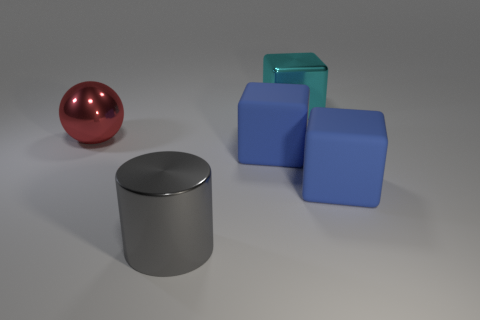There is a large metallic object that is in front of the red sphere; what is its color?
Offer a very short reply. Gray. Are there more shiny objects left of the gray cylinder than large yellow matte things?
Your answer should be very brief. Yes. The big sphere has what color?
Your answer should be compact. Red. There is a blue matte thing behind the large blue matte object that is on the right side of the thing that is behind the red ball; what shape is it?
Your answer should be very brief. Cube. What is the shape of the large metallic object behind the large metallic thing that is to the left of the large gray metal cylinder?
Your answer should be compact. Cube. There is a red metal sphere; is its size the same as the metal object right of the big gray metal cylinder?
Give a very brief answer. Yes. How many large things are blue rubber blocks or cylinders?
Your answer should be compact. 3. Is the number of large gray metallic cylinders greater than the number of blue rubber blocks?
Keep it short and to the point. No. What number of big blue objects are in front of the large rubber thing to the left of the metallic object that is behind the big red shiny thing?
Make the answer very short. 1. What shape is the cyan shiny thing?
Provide a short and direct response. Cube. 